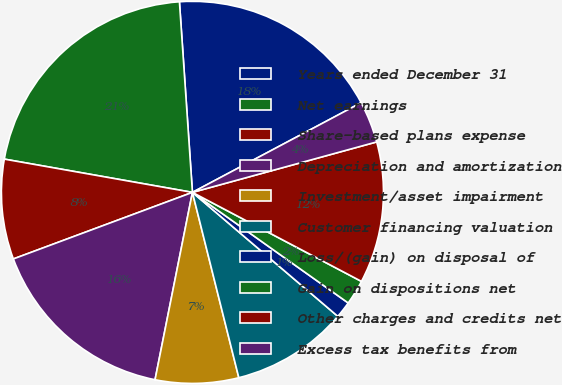Convert chart. <chart><loc_0><loc_0><loc_500><loc_500><pie_chart><fcel>Years ended December 31<fcel>Net earnings<fcel>Share-based plans expense<fcel>Depreciation and amortization<fcel>Investment/asset impairment<fcel>Customer financing valuation<fcel>Loss/(gain) on disposal of<fcel>Gain on dispositions net<fcel>Other charges and credits net<fcel>Excess tax benefits from<nl><fcel>18.31%<fcel>21.13%<fcel>8.45%<fcel>16.2%<fcel>7.04%<fcel>9.86%<fcel>1.41%<fcel>2.11%<fcel>11.97%<fcel>3.52%<nl></chart> 